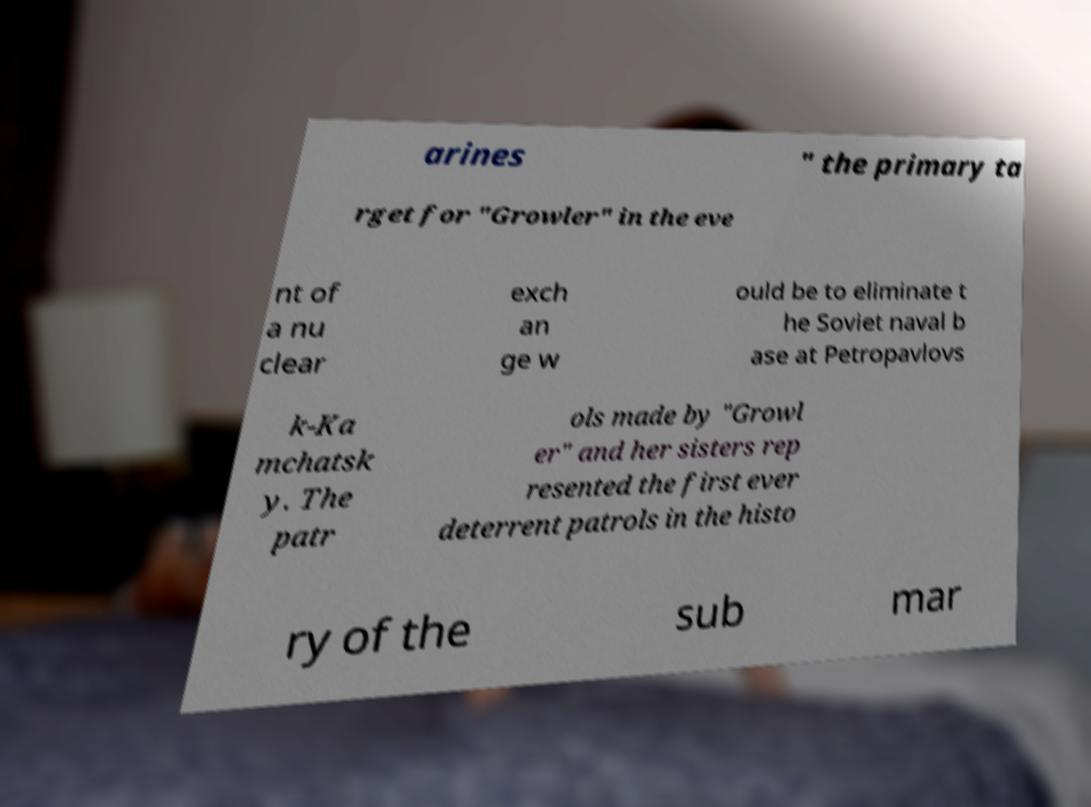Can you accurately transcribe the text from the provided image for me? arines " the primary ta rget for "Growler" in the eve nt of a nu clear exch an ge w ould be to eliminate t he Soviet naval b ase at Petropavlovs k-Ka mchatsk y. The patr ols made by "Growl er" and her sisters rep resented the first ever deterrent patrols in the histo ry of the sub mar 